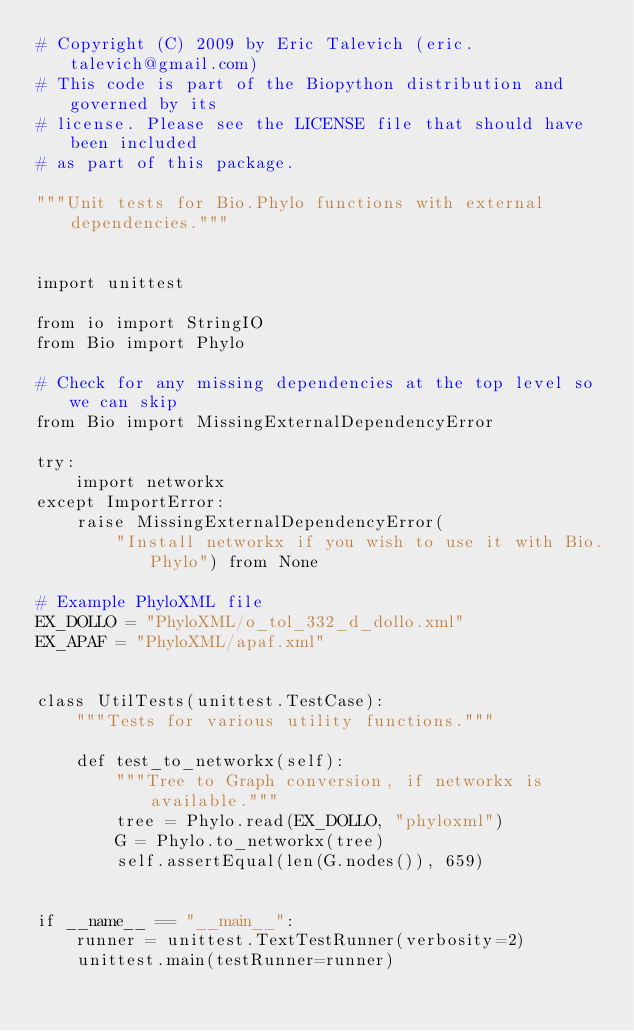<code> <loc_0><loc_0><loc_500><loc_500><_Python_># Copyright (C) 2009 by Eric Talevich (eric.talevich@gmail.com)
# This code is part of the Biopython distribution and governed by its
# license. Please see the LICENSE file that should have been included
# as part of this package.

"""Unit tests for Bio.Phylo functions with external dependencies."""


import unittest

from io import StringIO
from Bio import Phylo

# Check for any missing dependencies at the top level so we can skip
from Bio import MissingExternalDependencyError

try:
    import networkx
except ImportError:
    raise MissingExternalDependencyError(
        "Install networkx if you wish to use it with Bio.Phylo") from None

# Example PhyloXML file
EX_DOLLO = "PhyloXML/o_tol_332_d_dollo.xml"
EX_APAF = "PhyloXML/apaf.xml"


class UtilTests(unittest.TestCase):
    """Tests for various utility functions."""

    def test_to_networkx(self):
        """Tree to Graph conversion, if networkx is available."""
        tree = Phylo.read(EX_DOLLO, "phyloxml")
        G = Phylo.to_networkx(tree)
        self.assertEqual(len(G.nodes()), 659)


if __name__ == "__main__":
    runner = unittest.TextTestRunner(verbosity=2)
    unittest.main(testRunner=runner)
</code> 